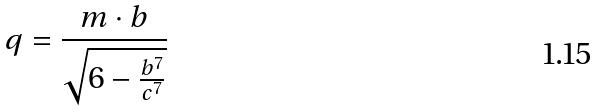Convert formula to latex. <formula><loc_0><loc_0><loc_500><loc_500>q = \frac { m \cdot b } { \sqrt { 6 - \frac { b ^ { 7 } } { c ^ { 7 } } } }</formula> 